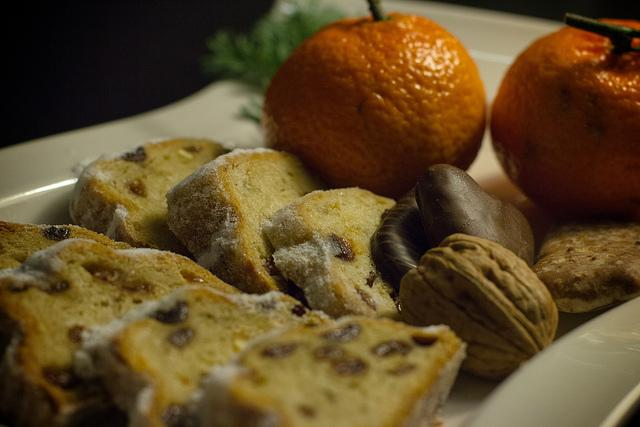What is the name of the nut on the plate? Please explain your reasoning. walnut. The hard shell is very distinguishable as a walnut. 